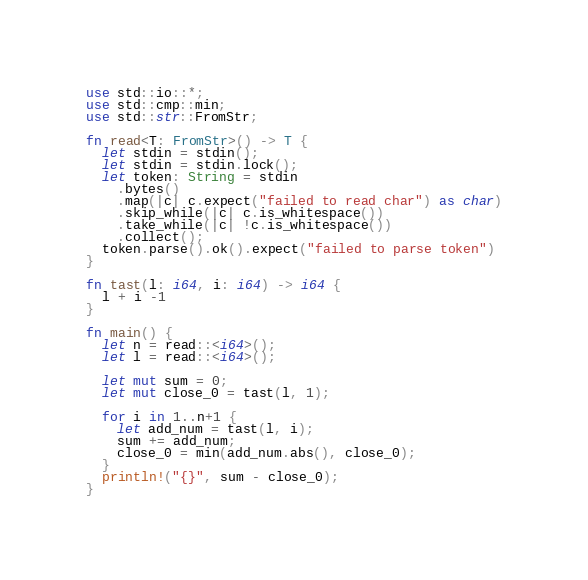Convert code to text. <code><loc_0><loc_0><loc_500><loc_500><_Rust_>use std::io::*;
use std::cmp::min;
use std::str::FromStr;

fn read<T: FromStr>() -> T {
  let stdin = stdin();
  let stdin = stdin.lock();
  let token: String = stdin
    .bytes()
    .map(|c| c.expect("failed to read char") as char)
    .skip_while(|c| c.is_whitespace())
    .take_while(|c| !c.is_whitespace())
    .collect();
  token.parse().ok().expect("failed to parse token")
}

fn tast(l: i64, i: i64) -> i64 {
  l + i -1
}

fn main() {
  let n = read::<i64>();
  let l = read::<i64>();

  let mut sum = 0;
  let mut close_0 = tast(l, 1);

  for i in 1..n+1 {
    let add_num = tast(l, i);
    sum += add_num;
    close_0 = min(add_num.abs(), close_0);
  }
  println!("{}", sum - close_0);
}
</code> 